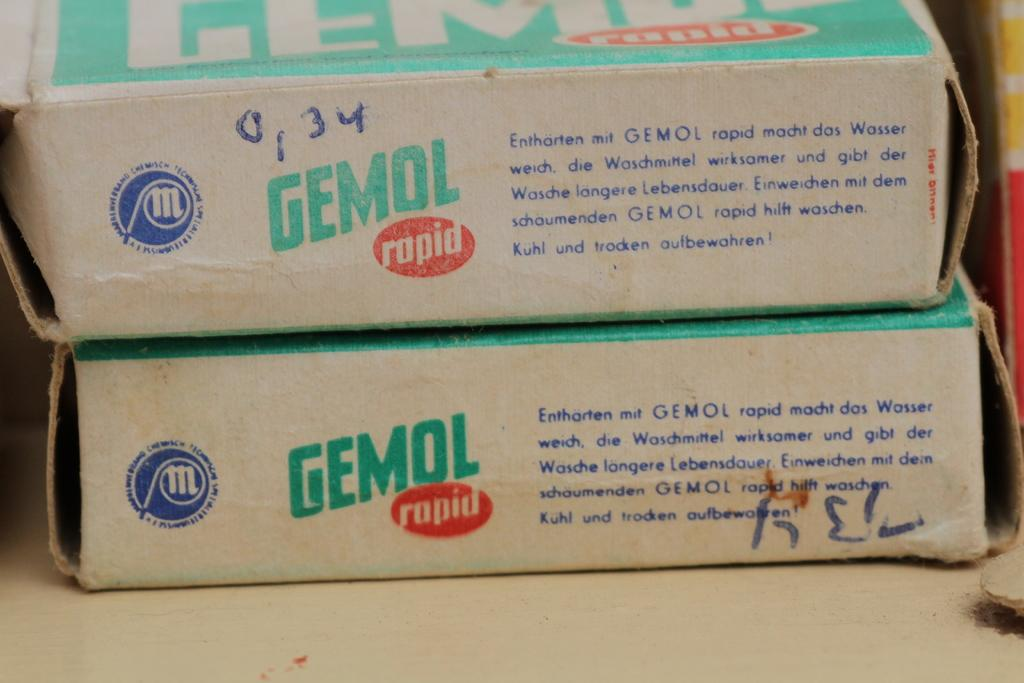<image>
Share a concise interpretation of the image provided. A side on image of two Gemol boxes with German text explaining what they contain. 